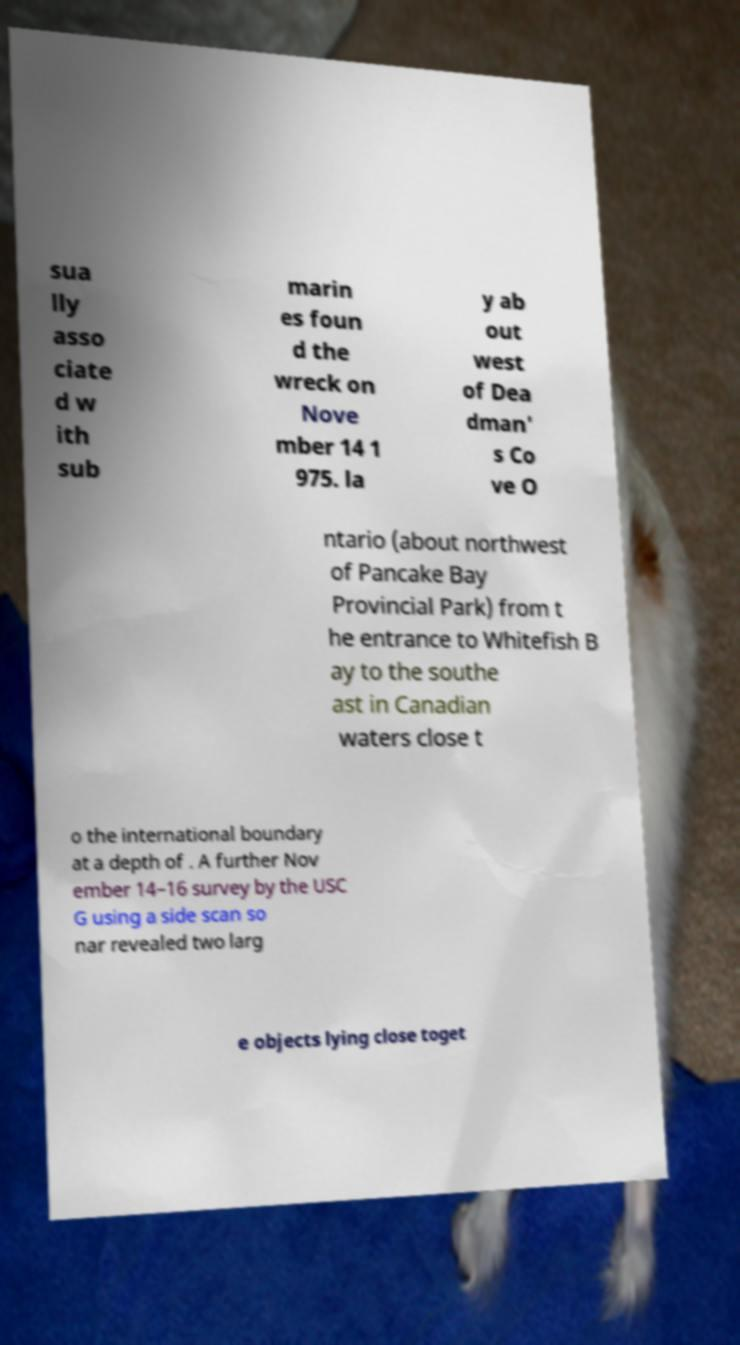Please identify and transcribe the text found in this image. sua lly asso ciate d w ith sub marin es foun d the wreck on Nove mber 14 1 975. la y ab out west of Dea dman' s Co ve O ntario (about northwest of Pancake Bay Provincial Park) from t he entrance to Whitefish B ay to the southe ast in Canadian waters close t o the international boundary at a depth of . A further Nov ember 14–16 survey by the USC G using a side scan so nar revealed two larg e objects lying close toget 